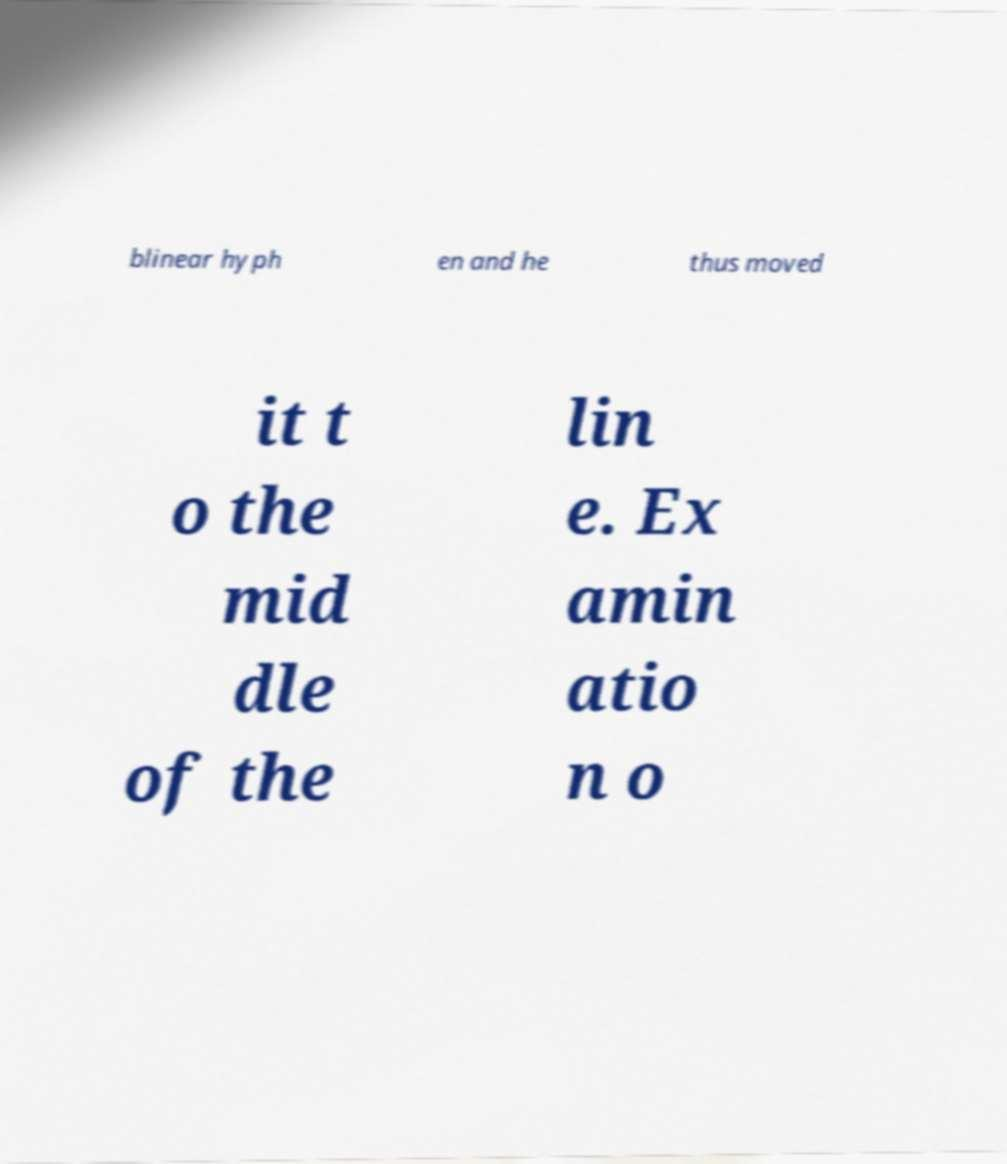Please identify and transcribe the text found in this image. blinear hyph en and he thus moved it t o the mid dle of the lin e. Ex amin atio n o 